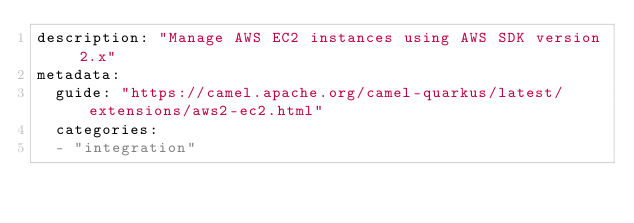<code> <loc_0><loc_0><loc_500><loc_500><_YAML_>description: "Manage AWS EC2 instances using AWS SDK version 2.x"
metadata:
  guide: "https://camel.apache.org/camel-quarkus/latest/extensions/aws2-ec2.html"
  categories:
  - "integration"
</code> 